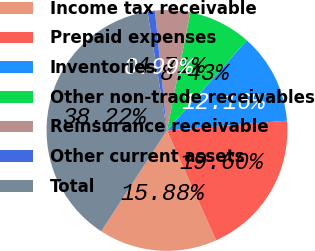<chart> <loc_0><loc_0><loc_500><loc_500><pie_chart><fcel>Income tax receivable<fcel>Prepaid expenses<fcel>Inventories<fcel>Other non-trade receivables<fcel>Reinsurance receivable<fcel>Other current assets<fcel>Total<nl><fcel>15.88%<fcel>19.6%<fcel>12.16%<fcel>8.43%<fcel>4.71%<fcel>0.99%<fcel>38.22%<nl></chart> 